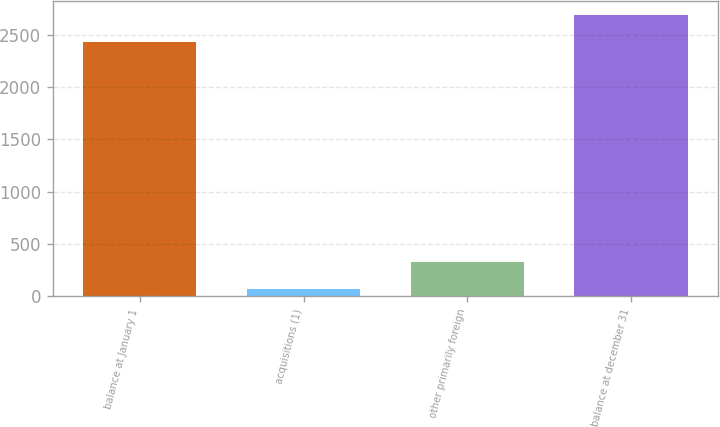Convert chart to OTSL. <chart><loc_0><loc_0><loc_500><loc_500><bar_chart><fcel>balance at January 1<fcel>acquisitions (1)<fcel>other primarily foreign<fcel>balance at december 31<nl><fcel>2435.7<fcel>71.8<fcel>325.49<fcel>2689.39<nl></chart> 